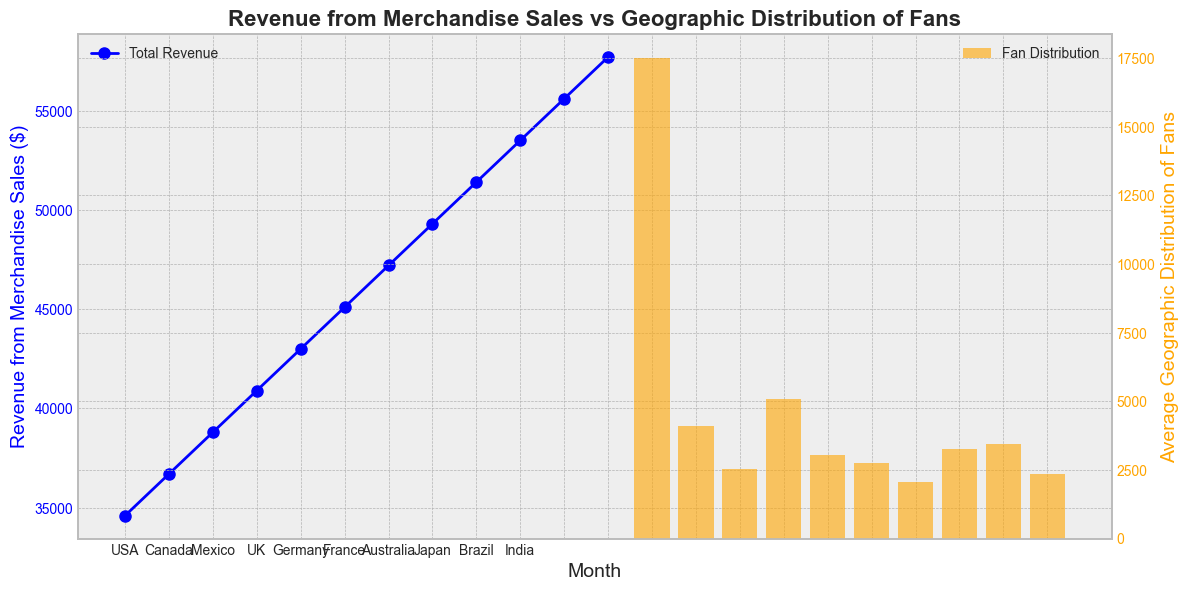What is the total revenue from merchandise sales in March? Look for the data point corresponding to March on the line plot (blue line). The line plot shows 'Total Revenue' for each month. The total revenue for March is at the point on the blue line on the x-axis labeled "Mar".
Answer: 14000 Which country has the highest average geographic distribution of fans? Examine the heights of the orange bars for each country on the secondary y-axis. The highest bar represents the country with the most significant average fan distribution. The highest bar is for the USA.
Answer: USA How does the total revenue change from January to December? Follow the blue line plot from January (the leftmost point) to December (the rightmost point). Notice the upward trend, indicating that total revenue increases from January to December.
Answer: Increases Calculate the average revenue from merchandise sales from January to June. Locate the data points on the blue line for January to June. Add these values (12000 + 13000 + 14000 + 15000 + 16000 + 17000) and divide by 6 to find the average. (12000 + 13000 + 14000 + 15000 + 16000 + 17000) ÷ 6 = 14500.
Answer: 14500 Compare the average geographic distribution of fans in Brazil to that of Japan. Which is higher? Observe the heights of the orange bars for Brazil and Japan on the secondary y-axis. The bar for Japan is taller than the bar for Brazil, indicating a higher average geographic distribution of fans in Japan.
Answer: Japan What is the difference in total revenue between August and September? Find the data points corresponding to August and September on the blue line plot. The revenue for August is 19000, and for September, it's 20000. Subtract the August value from the September value (20000 - 19000 = 1000).
Answer: 1000 Which month shows the highest total revenue? Identify the highest point on the blue line plot. The highest data point corresponds to December, indicating the highest total revenue.
Answer: December Is the average geographic distribution of fans higher in Canada or France? Look at the orange bars for Canada and France. The bar for Canada is taller than the bar for France, indicating a higher average geographic distribution in Canada.
Answer: Canada Calculate the total fan distribution across all countries. Sum the average fan distributions shown by the heights of the orange bars. This involves summing the values given for each country in the plot (USA, Canada, Mexico, UK, Germany, France, Australia, Japan, Brazil, India). Sum the average values directly from the figure.
Answer: (Answer will be a sum of numbers visible in the chart, specific numerical value cannot be determined from the data provided) What is the trend of total revenue from February to May? Look at the blue line plot from February to May. Notice that the line consistently slopes upwards, indicating that the revenue is increasing over this period.
Answer: Increasing 